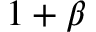<formula> <loc_0><loc_0><loc_500><loc_500>1 + \beta</formula> 